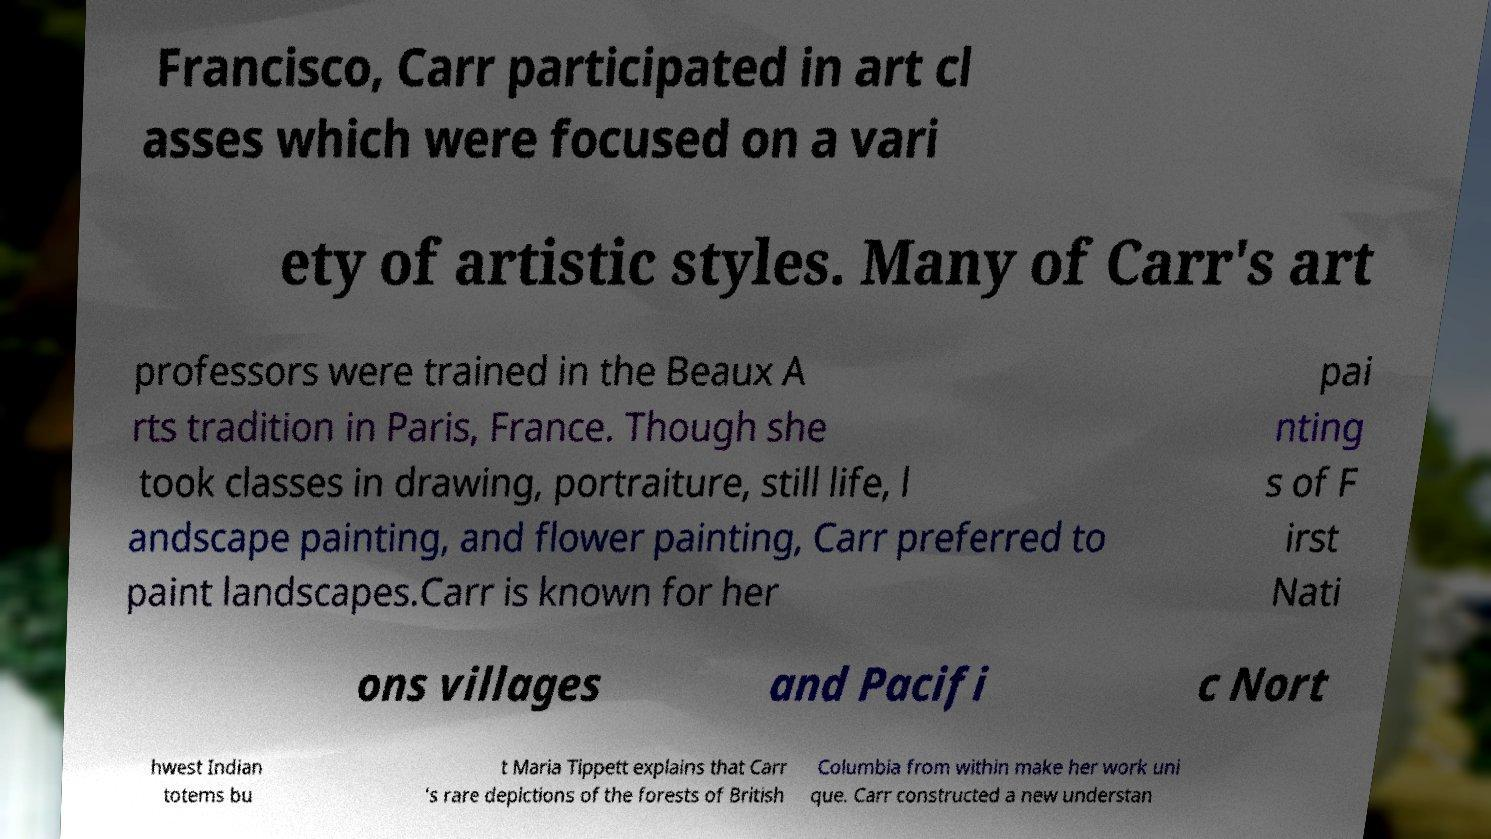What messages or text are displayed in this image? I need them in a readable, typed format. Francisco, Carr participated in art cl asses which were focused on a vari ety of artistic styles. Many of Carr's art professors were trained in the Beaux A rts tradition in Paris, France. Though she took classes in drawing, portraiture, still life, l andscape painting, and flower painting, Carr preferred to paint landscapes.Carr is known for her pai nting s of F irst Nati ons villages and Pacifi c Nort hwest Indian totems bu t Maria Tippett explains that Carr 's rare depictions of the forests of British Columbia from within make her work uni que. Carr constructed a new understan 